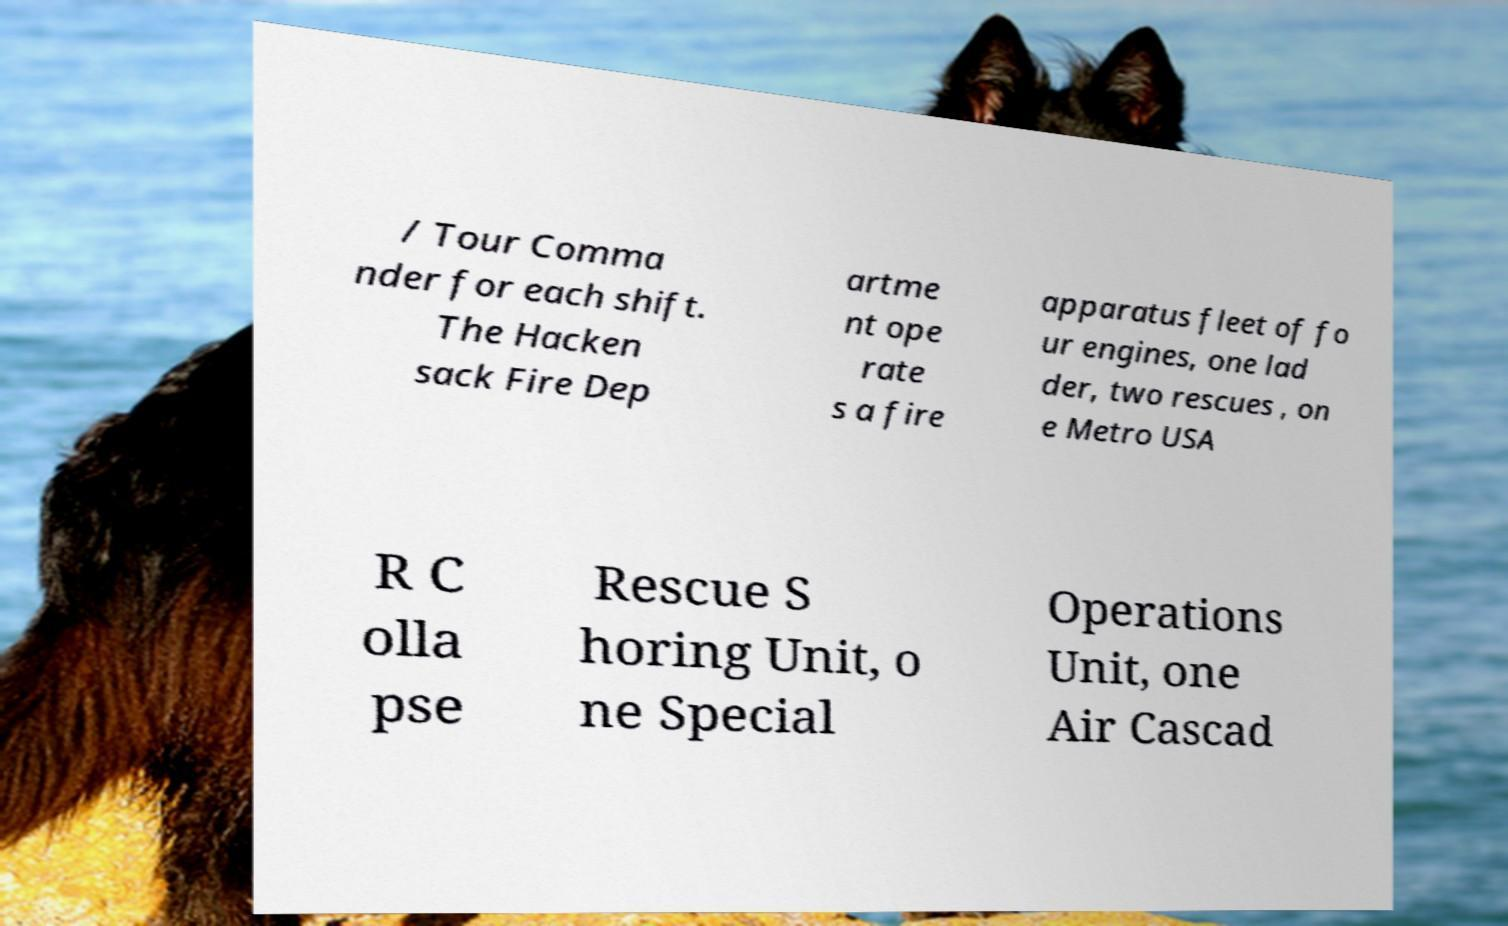There's text embedded in this image that I need extracted. Can you transcribe it verbatim? / Tour Comma nder for each shift. The Hacken sack Fire Dep artme nt ope rate s a fire apparatus fleet of fo ur engines, one lad der, two rescues , on e Metro USA R C olla pse Rescue S horing Unit, o ne Special Operations Unit, one Air Cascad 